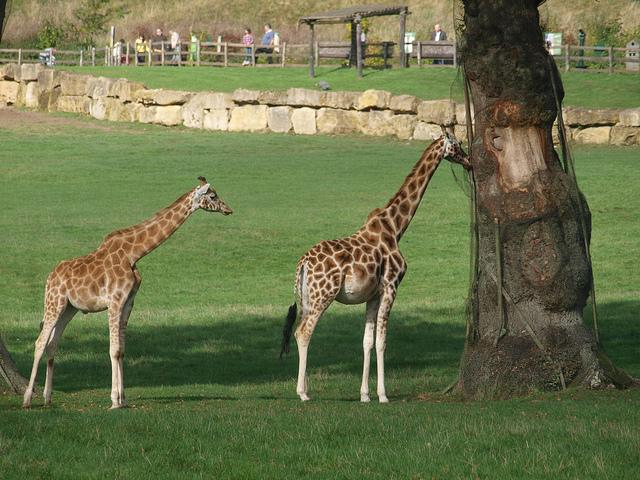How many giraffes are gathered around the tree with some mild damage? Please explain your reasoning. two. One giraffe is interacting with the tree. an additional giraffe is behind this one. 